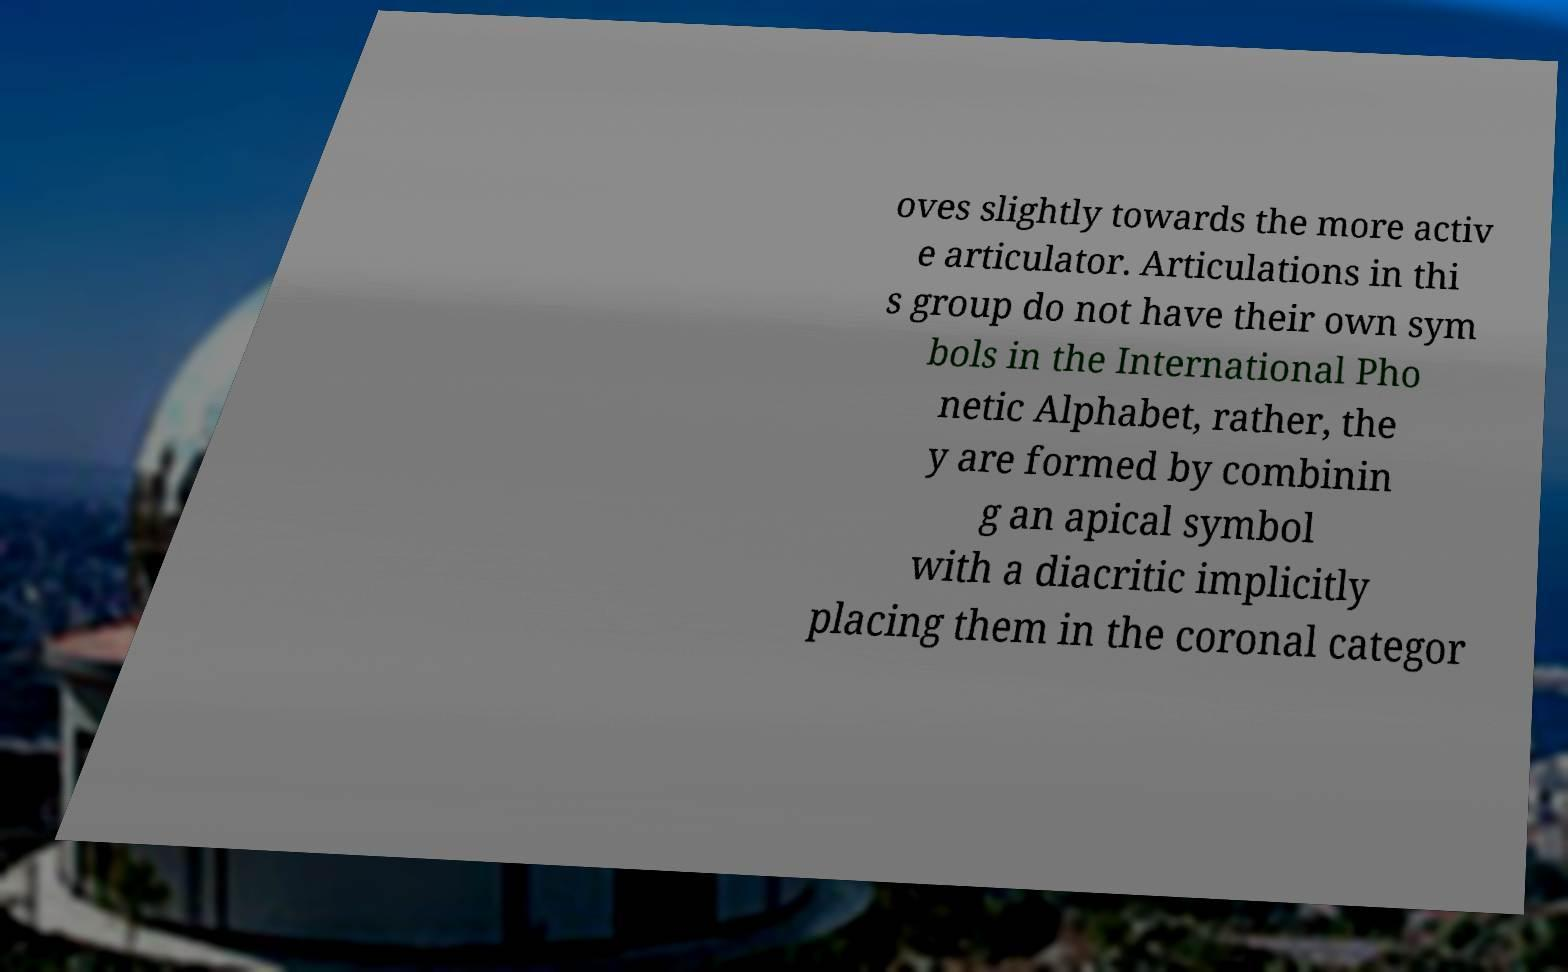What messages or text are displayed in this image? I need them in a readable, typed format. oves slightly towards the more activ e articulator. Articulations in thi s group do not have their own sym bols in the International Pho netic Alphabet, rather, the y are formed by combinin g an apical symbol with a diacritic implicitly placing them in the coronal categor 